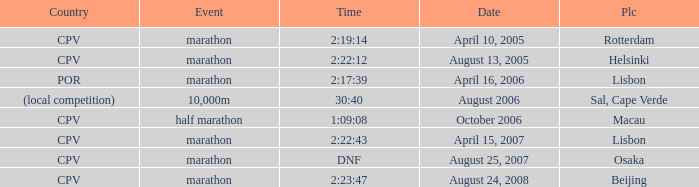What is the Event labeled Country of (local competition)? 10,000m. Would you mind parsing the complete table? {'header': ['Country', 'Event', 'Time', 'Date', 'Plc'], 'rows': [['CPV', 'marathon', '2:19:14', 'April 10, 2005', 'Rotterdam'], ['CPV', 'marathon', '2:22:12', 'August 13, 2005', 'Helsinki'], ['POR', 'marathon', '2:17:39', 'April 16, 2006', 'Lisbon'], ['(local competition)', '10,000m', '30:40', 'August 2006', 'Sal, Cape Verde'], ['CPV', 'half marathon', '1:09:08', 'October 2006', 'Macau'], ['CPV', 'marathon', '2:22:43', 'April 15, 2007', 'Lisbon'], ['CPV', 'marathon', 'DNF', 'August 25, 2007', 'Osaka'], ['CPV', 'marathon', '2:23:47', 'August 24, 2008', 'Beijing']]} 